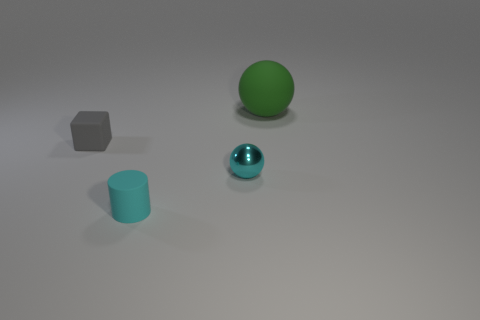Is there anything else that is the same material as the cyan ball?
Offer a very short reply. No. There is a sphere that is made of the same material as the tiny cyan cylinder; what is its size?
Ensure brevity in your answer.  Large. How many other objects are the same size as the rubber sphere?
Offer a terse response. 0. What material is the sphere in front of the green object?
Your answer should be compact. Metal. There is a cyan thing that is in front of the tiny cyan object right of the tiny rubber object in front of the cube; what shape is it?
Offer a terse response. Cylinder. Does the cyan rubber cylinder have the same size as the cyan ball?
Your answer should be compact. Yes. What number of objects are either metallic objects or spheres in front of the green matte thing?
Keep it short and to the point. 1. How many things are either objects that are right of the gray block or tiny objects that are in front of the cyan ball?
Ensure brevity in your answer.  3. Are there any tiny rubber objects in front of the gray matte thing?
Ensure brevity in your answer.  Yes. There is a matte object that is to the right of the tiny cyan object that is left of the tiny object that is to the right of the cylinder; what is its color?
Your response must be concise. Green. 